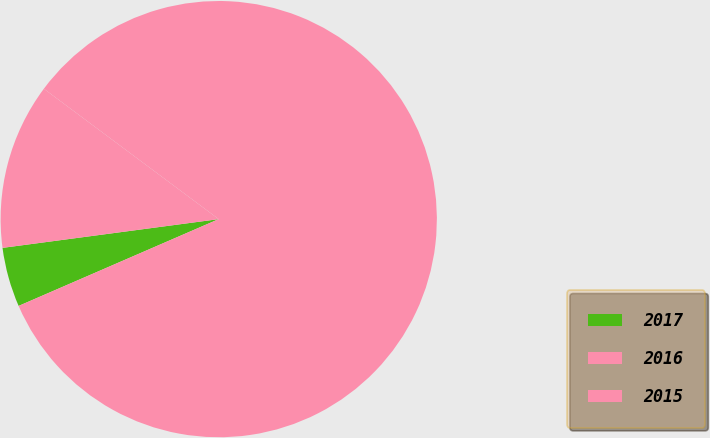Convert chart to OTSL. <chart><loc_0><loc_0><loc_500><loc_500><pie_chart><fcel>2017<fcel>2016<fcel>2015<nl><fcel>4.41%<fcel>83.29%<fcel>12.3%<nl></chart> 